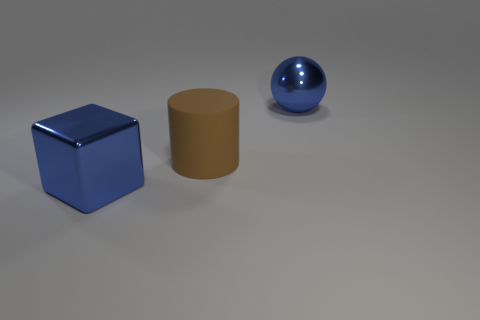What material is the large blue block?
Make the answer very short. Metal. There is a ball that is the same color as the large shiny cube; what is its material?
Your response must be concise. Metal. There is a big blue metallic thing to the left of the brown thing; is its shape the same as the large brown object?
Give a very brief answer. No. How many objects are gray shiny things or large metal cubes?
Provide a short and direct response. 1. Do the big thing that is on the right side of the cylinder and the big brown cylinder have the same material?
Provide a short and direct response. No. The brown thing is what size?
Your answer should be compact. Large. The object that is the same color as the big cube is what shape?
Offer a very short reply. Sphere. What number of spheres are yellow rubber objects or big blue objects?
Offer a very short reply. 1. Is the number of big brown rubber cylinders in front of the brown thing the same as the number of large metallic balls to the left of the blue cube?
Your answer should be compact. Yes. How big is the thing that is both behind the large shiny block and left of the metal sphere?
Make the answer very short. Large. 